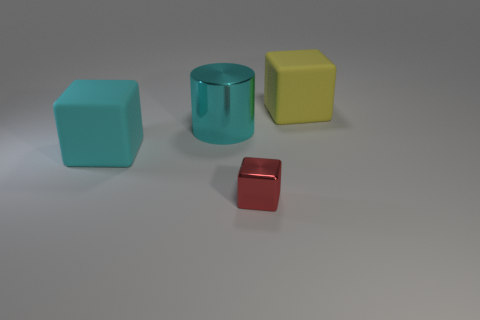Are these objects meant to represent something specific or are they just random shapes? These objects do not appear to represent anything specific; they seem to be simple geometric shapes, likely used here for illustrative or educational purposes, such as demonstrating spatial concepts or for a sorting activity. 